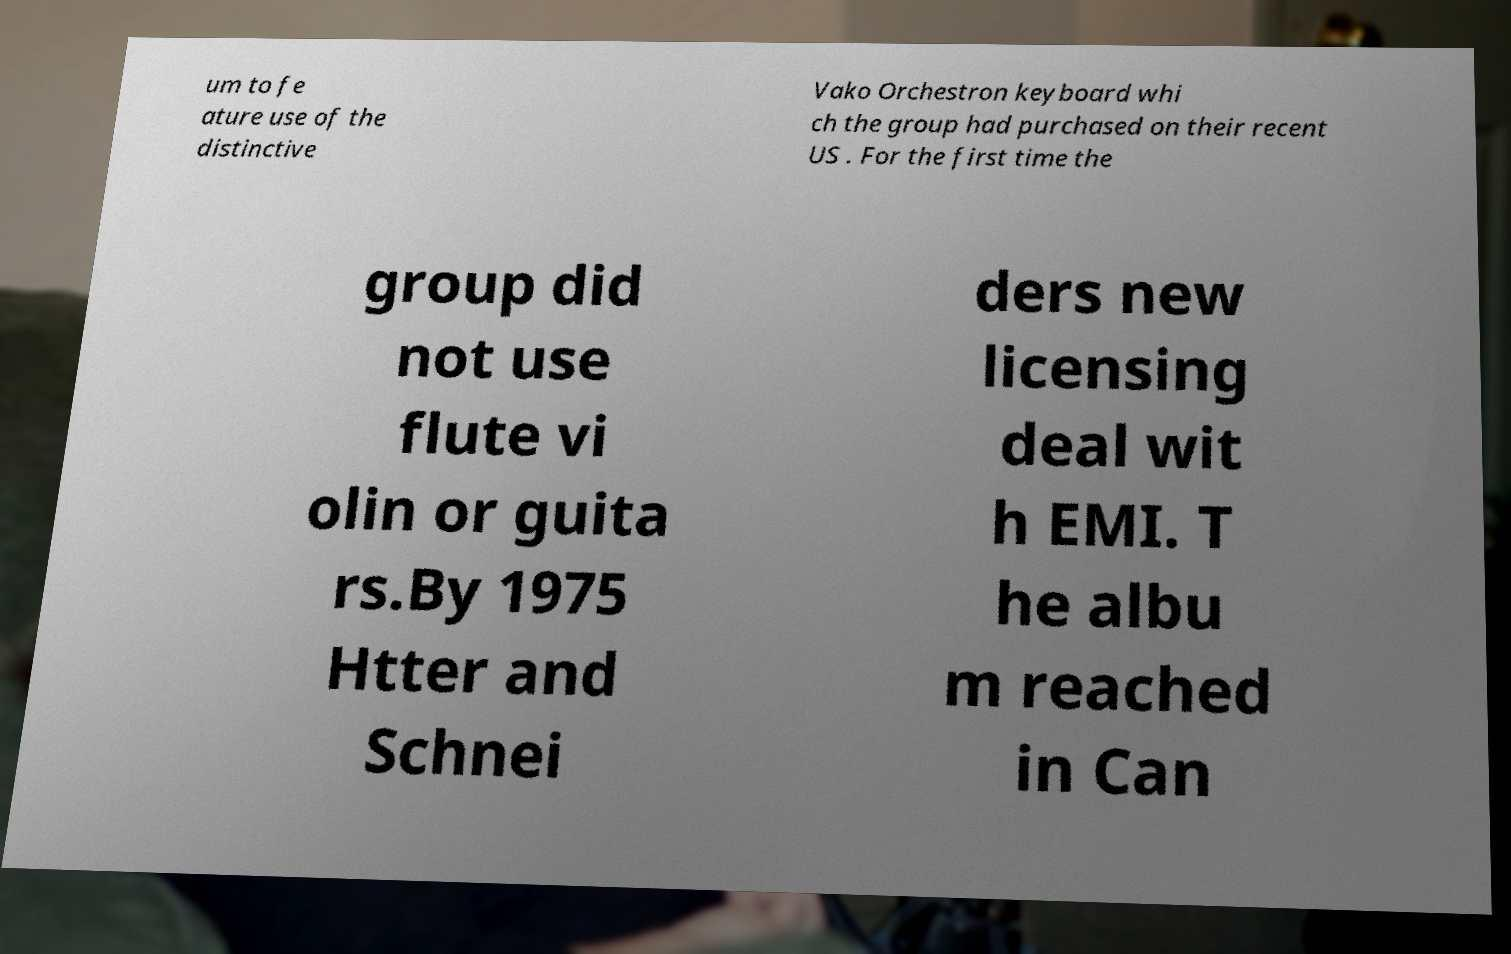What messages or text are displayed in this image? I need them in a readable, typed format. um to fe ature use of the distinctive Vako Orchestron keyboard whi ch the group had purchased on their recent US . For the first time the group did not use flute vi olin or guita rs.By 1975 Htter and Schnei ders new licensing deal wit h EMI. T he albu m reached in Can 